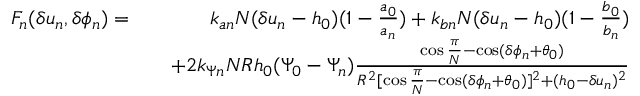<formula> <loc_0><loc_0><loc_500><loc_500>\begin{array} { r l r } { F _ { n } ( \delta u _ { n } , \delta \phi _ { n } ) = } & { k _ { a n } N ( \delta u _ { n } - h _ { 0 } ) ( 1 - \frac { a _ { 0 } } { a _ { n } } ) + k _ { b n } N ( \delta u _ { n } - h _ { 0 } ) ( 1 - \frac { b _ { 0 } } { b _ { n } } ) } \\ & { + 2 k _ { \Psi n } N R h _ { 0 } ( \Psi _ { 0 } - \Psi _ { n } ) \frac { \cos \frac { \pi } { N } - \cos ( \delta \phi _ { n } + \theta _ { 0 } ) } { R ^ { 2 } [ \cos \frac { \pi } { N } - \cos ( \delta \phi _ { n } + \theta _ { 0 } ) ] ^ { 2 } + ( h _ { 0 } - \delta u _ { n } ) ^ { 2 } } } \end{array}</formula> 